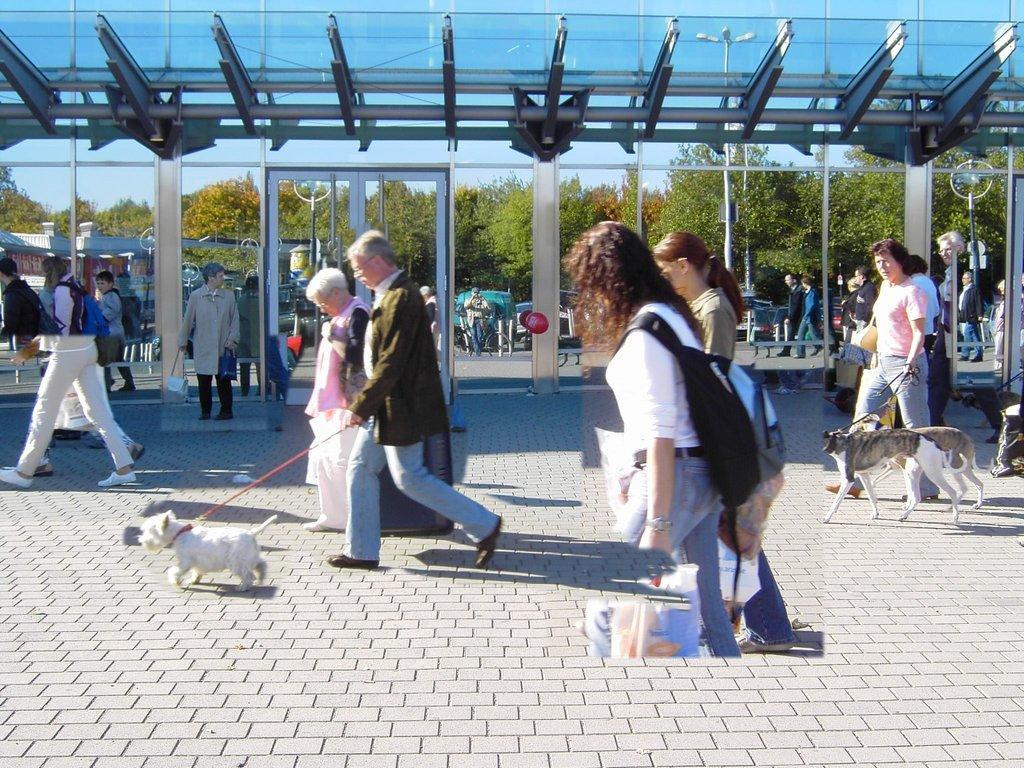In one or two sentences, can you explain what this image depicts? In this image a person is walking by holding the belt of the dog and a woman is beside him. At the front side of the image womens are walking. This woman is holding and carrying bag. At the left side of image few people are walking. At the background few vehicles are parked and trees and sky is there at the background of the image. 